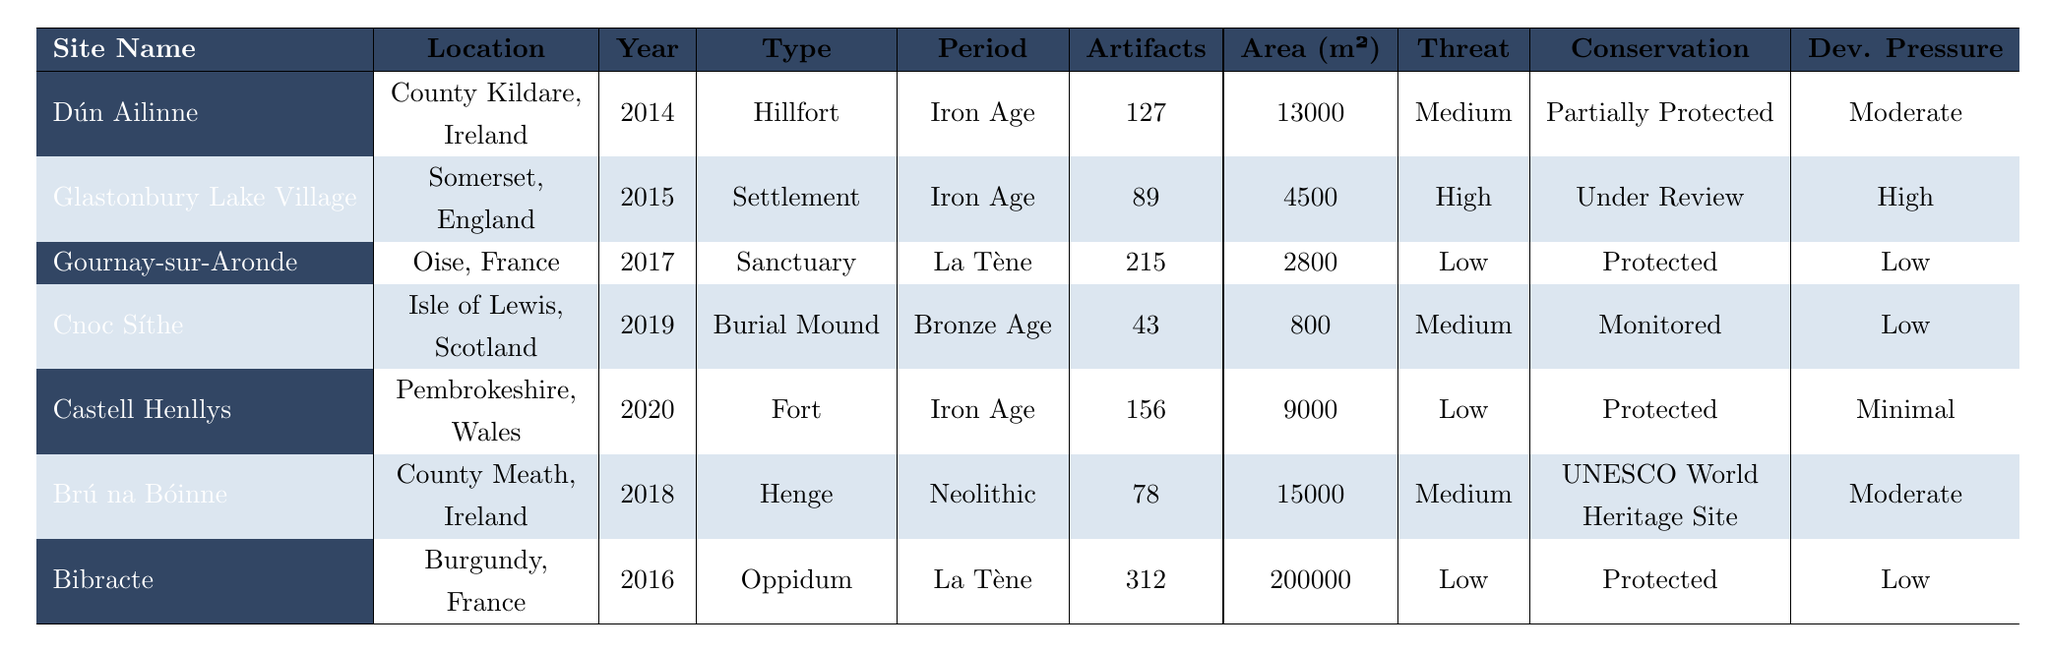What is the total number of artifacts found at all the sites combined? We sum the artifacts found at each site: 127 + 89 + 215 + 43 + 156 + 78 + 312 = 1020.
Answer: 1020 Which site has the highest threat level? The threat levels are listed as Medium, High, Low. Glastonbury Lake Village is labeled as High, which is the highest level among all sites.
Answer: Glastonbury Lake Village What is the average area size of the sites in square meters? We calculate the total area: 13000 + 4500 + 2800 + 800 + 9000 + 15000 + 200000 = 242100. There are 7 sites, so the average is 242100 / 7 = 34557.14.
Answer: 34557.14 How many sites are classified as "Protected"? The sites Gournay-sur-Aronde, Castell Henllys, and Bibracte are labeled as Protected, making a total of 3 sites.
Answer: 3 Is the site Dún Ailinne classified as "UNESCO World Heritage Site"? Dún Ailinne is classified as "Partially Protected," not "UNESCO World Heritage Site," so the statement is false.
Answer: No What is the difference in area size between the largest site and the smallest site? The largest site is Bibracte with 200000 m², and the smallest is Cnoc Síthe with 800 m². The difference is 200000 - 800 = 199200 m².
Answer: 199200 Which period has the most occurrences among the sites? The periods are Iron Age (4 occurrences), La Tène (3 occurrences), and Neolithic (1 occurrence). Iron Age has the highest occurrences with 4 sites.
Answer: Iron Age How many sites are facing high development pressure? Glastonbury Lake Village is the only site listed under "High" development pressure, so there is 1 site.
Answer: 1 Are there any sites discovered before 2015 that are classified as "Monitored"? Cnoc Síthe, discovered in 2019, is the only site classified as "Monitored", and it was discovered after 2015, hence the answer is false.
Answer: No What percentage of sites are classified as having "Low" threat levels? There are 7 sites total, with 3 having Low threat levels (Gournay-sur-Aronde, Bibracte, and Castell Henllys). The percentage is (3/7) * 100 = 42.86%.
Answer: 42.86% 